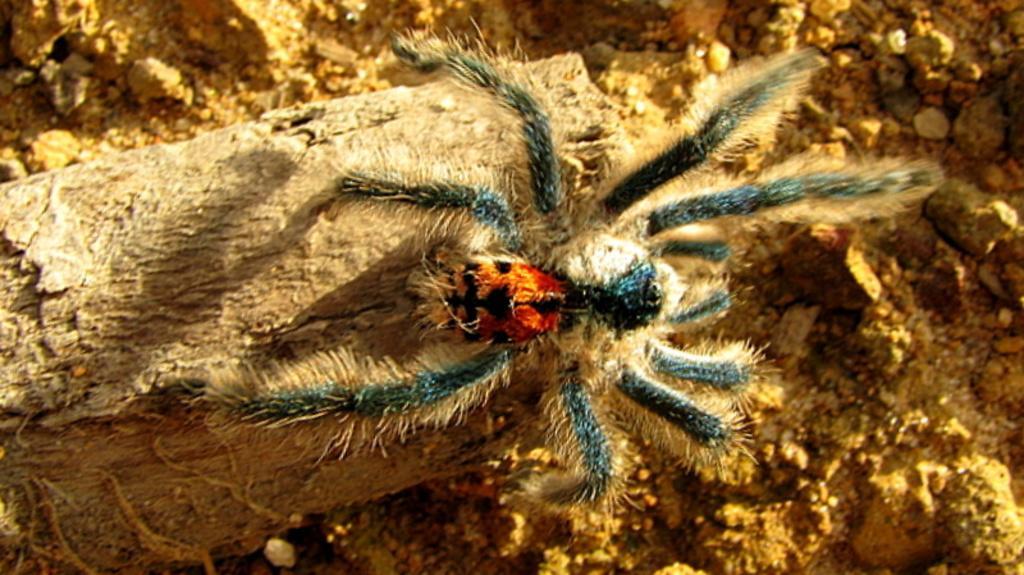Please provide a concise description of this image. In the picture we can see a spider which is in different color is on the wooden surface. 